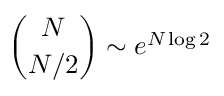Convert formula to latex. <formula><loc_0><loc_0><loc_500><loc_500>\binom { N } { N / 2 } \sim e ^ { N \log 2 }</formula> 